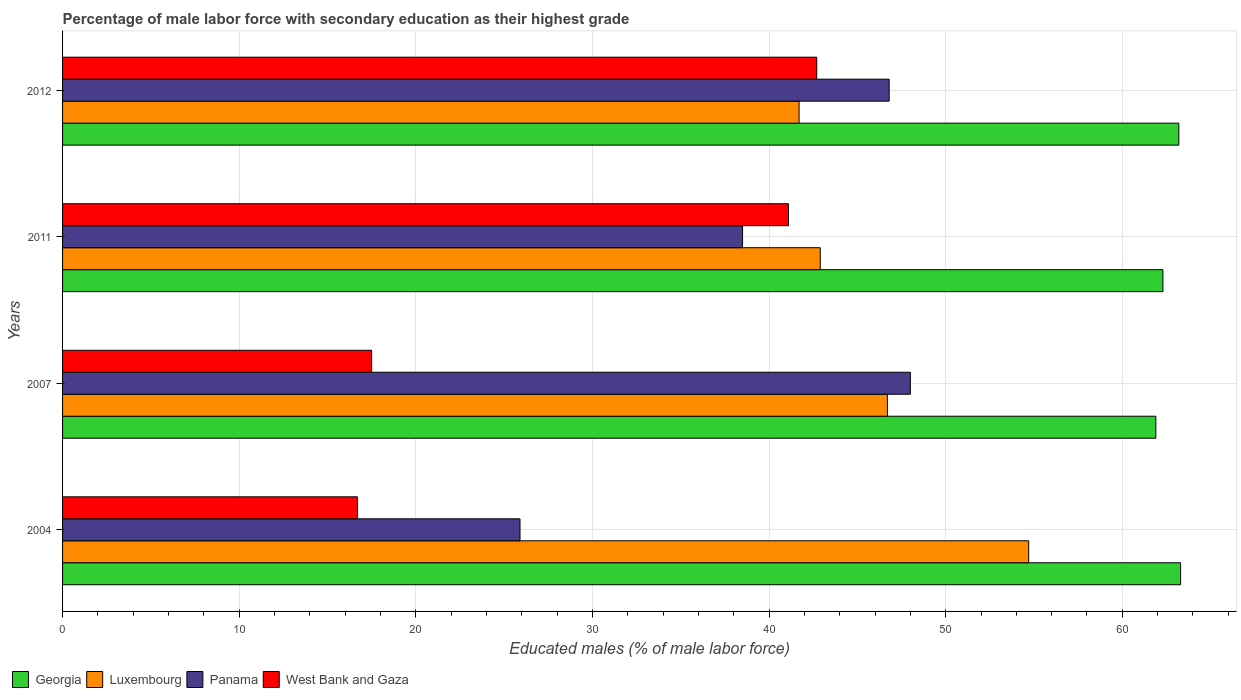How many different coloured bars are there?
Provide a succinct answer. 4. How many groups of bars are there?
Ensure brevity in your answer.  4. Are the number of bars on each tick of the Y-axis equal?
Provide a succinct answer. Yes. How many bars are there on the 3rd tick from the top?
Offer a very short reply. 4. How many bars are there on the 1st tick from the bottom?
Provide a succinct answer. 4. In how many cases, is the number of bars for a given year not equal to the number of legend labels?
Keep it short and to the point. 0. What is the percentage of male labor force with secondary education in Luxembourg in 2007?
Your answer should be very brief. 46.7. Across all years, what is the maximum percentage of male labor force with secondary education in Luxembourg?
Your answer should be very brief. 54.7. Across all years, what is the minimum percentage of male labor force with secondary education in Georgia?
Your response must be concise. 61.9. In which year was the percentage of male labor force with secondary education in West Bank and Gaza maximum?
Ensure brevity in your answer.  2012. What is the total percentage of male labor force with secondary education in West Bank and Gaza in the graph?
Offer a terse response. 118. What is the difference between the percentage of male labor force with secondary education in Georgia in 2004 and that in 2011?
Make the answer very short. 1. What is the difference between the percentage of male labor force with secondary education in West Bank and Gaza in 2004 and the percentage of male labor force with secondary education in Luxembourg in 2012?
Provide a succinct answer. -25. What is the average percentage of male labor force with secondary education in Luxembourg per year?
Give a very brief answer. 46.5. In the year 2012, what is the difference between the percentage of male labor force with secondary education in Luxembourg and percentage of male labor force with secondary education in Georgia?
Provide a succinct answer. -21.5. What is the ratio of the percentage of male labor force with secondary education in Luxembourg in 2004 to that in 2007?
Keep it short and to the point. 1.17. Is the percentage of male labor force with secondary education in West Bank and Gaza in 2007 less than that in 2012?
Provide a short and direct response. Yes. What is the difference between the highest and the second highest percentage of male labor force with secondary education in Georgia?
Make the answer very short. 0.1. What is the difference between the highest and the lowest percentage of male labor force with secondary education in Panama?
Make the answer very short. 22.1. In how many years, is the percentage of male labor force with secondary education in West Bank and Gaza greater than the average percentage of male labor force with secondary education in West Bank and Gaza taken over all years?
Your response must be concise. 2. What does the 2nd bar from the top in 2012 represents?
Offer a very short reply. Panama. What does the 2nd bar from the bottom in 2004 represents?
Make the answer very short. Luxembourg. Are all the bars in the graph horizontal?
Provide a short and direct response. Yes. How many years are there in the graph?
Make the answer very short. 4. What is the difference between two consecutive major ticks on the X-axis?
Provide a short and direct response. 10. Where does the legend appear in the graph?
Keep it short and to the point. Bottom left. What is the title of the graph?
Provide a short and direct response. Percentage of male labor force with secondary education as their highest grade. Does "Zimbabwe" appear as one of the legend labels in the graph?
Give a very brief answer. No. What is the label or title of the X-axis?
Keep it short and to the point. Educated males (% of male labor force). What is the label or title of the Y-axis?
Provide a succinct answer. Years. What is the Educated males (% of male labor force) of Georgia in 2004?
Give a very brief answer. 63.3. What is the Educated males (% of male labor force) in Luxembourg in 2004?
Ensure brevity in your answer.  54.7. What is the Educated males (% of male labor force) in Panama in 2004?
Provide a succinct answer. 25.9. What is the Educated males (% of male labor force) in West Bank and Gaza in 2004?
Your response must be concise. 16.7. What is the Educated males (% of male labor force) of Georgia in 2007?
Keep it short and to the point. 61.9. What is the Educated males (% of male labor force) in Luxembourg in 2007?
Give a very brief answer. 46.7. What is the Educated males (% of male labor force) of West Bank and Gaza in 2007?
Your response must be concise. 17.5. What is the Educated males (% of male labor force) of Georgia in 2011?
Offer a very short reply. 62.3. What is the Educated males (% of male labor force) in Luxembourg in 2011?
Your answer should be very brief. 42.9. What is the Educated males (% of male labor force) of Panama in 2011?
Keep it short and to the point. 38.5. What is the Educated males (% of male labor force) in West Bank and Gaza in 2011?
Keep it short and to the point. 41.1. What is the Educated males (% of male labor force) of Georgia in 2012?
Your answer should be very brief. 63.2. What is the Educated males (% of male labor force) in Luxembourg in 2012?
Offer a very short reply. 41.7. What is the Educated males (% of male labor force) of Panama in 2012?
Give a very brief answer. 46.8. What is the Educated males (% of male labor force) of West Bank and Gaza in 2012?
Ensure brevity in your answer.  42.7. Across all years, what is the maximum Educated males (% of male labor force) in Georgia?
Your response must be concise. 63.3. Across all years, what is the maximum Educated males (% of male labor force) in Luxembourg?
Your response must be concise. 54.7. Across all years, what is the maximum Educated males (% of male labor force) in West Bank and Gaza?
Your response must be concise. 42.7. Across all years, what is the minimum Educated males (% of male labor force) in Georgia?
Make the answer very short. 61.9. Across all years, what is the minimum Educated males (% of male labor force) of Luxembourg?
Offer a terse response. 41.7. Across all years, what is the minimum Educated males (% of male labor force) in Panama?
Your response must be concise. 25.9. Across all years, what is the minimum Educated males (% of male labor force) in West Bank and Gaza?
Your answer should be very brief. 16.7. What is the total Educated males (% of male labor force) in Georgia in the graph?
Provide a short and direct response. 250.7. What is the total Educated males (% of male labor force) of Luxembourg in the graph?
Provide a succinct answer. 186. What is the total Educated males (% of male labor force) in Panama in the graph?
Make the answer very short. 159.2. What is the total Educated males (% of male labor force) in West Bank and Gaza in the graph?
Your response must be concise. 118. What is the difference between the Educated males (% of male labor force) of Georgia in 2004 and that in 2007?
Ensure brevity in your answer.  1.4. What is the difference between the Educated males (% of male labor force) in Panama in 2004 and that in 2007?
Ensure brevity in your answer.  -22.1. What is the difference between the Educated males (% of male labor force) in Panama in 2004 and that in 2011?
Make the answer very short. -12.6. What is the difference between the Educated males (% of male labor force) in West Bank and Gaza in 2004 and that in 2011?
Offer a very short reply. -24.4. What is the difference between the Educated males (% of male labor force) of Georgia in 2004 and that in 2012?
Provide a succinct answer. 0.1. What is the difference between the Educated males (% of male labor force) of Luxembourg in 2004 and that in 2012?
Give a very brief answer. 13. What is the difference between the Educated males (% of male labor force) of Panama in 2004 and that in 2012?
Provide a short and direct response. -20.9. What is the difference between the Educated males (% of male labor force) in Georgia in 2007 and that in 2011?
Provide a short and direct response. -0.4. What is the difference between the Educated males (% of male labor force) of Luxembourg in 2007 and that in 2011?
Offer a very short reply. 3.8. What is the difference between the Educated males (% of male labor force) of Panama in 2007 and that in 2011?
Provide a succinct answer. 9.5. What is the difference between the Educated males (% of male labor force) of West Bank and Gaza in 2007 and that in 2011?
Make the answer very short. -23.6. What is the difference between the Educated males (% of male labor force) of Luxembourg in 2007 and that in 2012?
Your response must be concise. 5. What is the difference between the Educated males (% of male labor force) of Panama in 2007 and that in 2012?
Your answer should be compact. 1.2. What is the difference between the Educated males (% of male labor force) in West Bank and Gaza in 2007 and that in 2012?
Provide a short and direct response. -25.2. What is the difference between the Educated males (% of male labor force) in Panama in 2011 and that in 2012?
Your answer should be compact. -8.3. What is the difference between the Educated males (% of male labor force) in West Bank and Gaza in 2011 and that in 2012?
Ensure brevity in your answer.  -1.6. What is the difference between the Educated males (% of male labor force) in Georgia in 2004 and the Educated males (% of male labor force) in Luxembourg in 2007?
Offer a terse response. 16.6. What is the difference between the Educated males (% of male labor force) of Georgia in 2004 and the Educated males (% of male labor force) of Panama in 2007?
Offer a terse response. 15.3. What is the difference between the Educated males (% of male labor force) in Georgia in 2004 and the Educated males (% of male labor force) in West Bank and Gaza in 2007?
Your response must be concise. 45.8. What is the difference between the Educated males (% of male labor force) of Luxembourg in 2004 and the Educated males (% of male labor force) of Panama in 2007?
Provide a short and direct response. 6.7. What is the difference between the Educated males (% of male labor force) in Luxembourg in 2004 and the Educated males (% of male labor force) in West Bank and Gaza in 2007?
Give a very brief answer. 37.2. What is the difference between the Educated males (% of male labor force) in Panama in 2004 and the Educated males (% of male labor force) in West Bank and Gaza in 2007?
Keep it short and to the point. 8.4. What is the difference between the Educated males (% of male labor force) in Georgia in 2004 and the Educated males (% of male labor force) in Luxembourg in 2011?
Provide a succinct answer. 20.4. What is the difference between the Educated males (% of male labor force) in Georgia in 2004 and the Educated males (% of male labor force) in Panama in 2011?
Keep it short and to the point. 24.8. What is the difference between the Educated males (% of male labor force) in Luxembourg in 2004 and the Educated males (% of male labor force) in Panama in 2011?
Make the answer very short. 16.2. What is the difference between the Educated males (% of male labor force) of Luxembourg in 2004 and the Educated males (% of male labor force) of West Bank and Gaza in 2011?
Your answer should be very brief. 13.6. What is the difference between the Educated males (% of male labor force) in Panama in 2004 and the Educated males (% of male labor force) in West Bank and Gaza in 2011?
Provide a short and direct response. -15.2. What is the difference between the Educated males (% of male labor force) of Georgia in 2004 and the Educated males (% of male labor force) of Luxembourg in 2012?
Keep it short and to the point. 21.6. What is the difference between the Educated males (% of male labor force) in Georgia in 2004 and the Educated males (% of male labor force) in Panama in 2012?
Your answer should be very brief. 16.5. What is the difference between the Educated males (% of male labor force) in Georgia in 2004 and the Educated males (% of male labor force) in West Bank and Gaza in 2012?
Offer a terse response. 20.6. What is the difference between the Educated males (% of male labor force) of Luxembourg in 2004 and the Educated males (% of male labor force) of Panama in 2012?
Make the answer very short. 7.9. What is the difference between the Educated males (% of male labor force) in Luxembourg in 2004 and the Educated males (% of male labor force) in West Bank and Gaza in 2012?
Ensure brevity in your answer.  12. What is the difference between the Educated males (% of male labor force) in Panama in 2004 and the Educated males (% of male labor force) in West Bank and Gaza in 2012?
Ensure brevity in your answer.  -16.8. What is the difference between the Educated males (% of male labor force) of Georgia in 2007 and the Educated males (% of male labor force) of Panama in 2011?
Make the answer very short. 23.4. What is the difference between the Educated males (% of male labor force) in Georgia in 2007 and the Educated males (% of male labor force) in West Bank and Gaza in 2011?
Keep it short and to the point. 20.8. What is the difference between the Educated males (% of male labor force) of Luxembourg in 2007 and the Educated males (% of male labor force) of Panama in 2011?
Offer a terse response. 8.2. What is the difference between the Educated males (% of male labor force) in Luxembourg in 2007 and the Educated males (% of male labor force) in West Bank and Gaza in 2011?
Make the answer very short. 5.6. What is the difference between the Educated males (% of male labor force) in Georgia in 2007 and the Educated males (% of male labor force) in Luxembourg in 2012?
Your response must be concise. 20.2. What is the difference between the Educated males (% of male labor force) of Luxembourg in 2007 and the Educated males (% of male labor force) of Panama in 2012?
Provide a succinct answer. -0.1. What is the difference between the Educated males (% of male labor force) of Luxembourg in 2007 and the Educated males (% of male labor force) of West Bank and Gaza in 2012?
Provide a short and direct response. 4. What is the difference between the Educated males (% of male labor force) in Panama in 2007 and the Educated males (% of male labor force) in West Bank and Gaza in 2012?
Ensure brevity in your answer.  5.3. What is the difference between the Educated males (% of male labor force) in Georgia in 2011 and the Educated males (% of male labor force) in Luxembourg in 2012?
Offer a very short reply. 20.6. What is the difference between the Educated males (% of male labor force) in Georgia in 2011 and the Educated males (% of male labor force) in West Bank and Gaza in 2012?
Make the answer very short. 19.6. What is the difference between the Educated males (% of male labor force) of Luxembourg in 2011 and the Educated males (% of male labor force) of Panama in 2012?
Ensure brevity in your answer.  -3.9. What is the difference between the Educated males (% of male labor force) in Panama in 2011 and the Educated males (% of male labor force) in West Bank and Gaza in 2012?
Your response must be concise. -4.2. What is the average Educated males (% of male labor force) of Georgia per year?
Keep it short and to the point. 62.67. What is the average Educated males (% of male labor force) of Luxembourg per year?
Ensure brevity in your answer.  46.5. What is the average Educated males (% of male labor force) in Panama per year?
Ensure brevity in your answer.  39.8. What is the average Educated males (% of male labor force) of West Bank and Gaza per year?
Your answer should be compact. 29.5. In the year 2004, what is the difference between the Educated males (% of male labor force) in Georgia and Educated males (% of male labor force) in Panama?
Offer a terse response. 37.4. In the year 2004, what is the difference between the Educated males (% of male labor force) in Georgia and Educated males (% of male labor force) in West Bank and Gaza?
Your answer should be compact. 46.6. In the year 2004, what is the difference between the Educated males (% of male labor force) of Luxembourg and Educated males (% of male labor force) of Panama?
Your answer should be compact. 28.8. In the year 2004, what is the difference between the Educated males (% of male labor force) of Luxembourg and Educated males (% of male labor force) of West Bank and Gaza?
Give a very brief answer. 38. In the year 2004, what is the difference between the Educated males (% of male labor force) of Panama and Educated males (% of male labor force) of West Bank and Gaza?
Offer a very short reply. 9.2. In the year 2007, what is the difference between the Educated males (% of male labor force) of Georgia and Educated males (% of male labor force) of West Bank and Gaza?
Offer a terse response. 44.4. In the year 2007, what is the difference between the Educated males (% of male labor force) of Luxembourg and Educated males (% of male labor force) of Panama?
Give a very brief answer. -1.3. In the year 2007, what is the difference between the Educated males (% of male labor force) of Luxembourg and Educated males (% of male labor force) of West Bank and Gaza?
Your response must be concise. 29.2. In the year 2007, what is the difference between the Educated males (% of male labor force) of Panama and Educated males (% of male labor force) of West Bank and Gaza?
Keep it short and to the point. 30.5. In the year 2011, what is the difference between the Educated males (% of male labor force) in Georgia and Educated males (% of male labor force) in Panama?
Make the answer very short. 23.8. In the year 2011, what is the difference between the Educated males (% of male labor force) of Georgia and Educated males (% of male labor force) of West Bank and Gaza?
Provide a short and direct response. 21.2. In the year 2011, what is the difference between the Educated males (% of male labor force) of Panama and Educated males (% of male labor force) of West Bank and Gaza?
Make the answer very short. -2.6. In the year 2012, what is the difference between the Educated males (% of male labor force) of Georgia and Educated males (% of male labor force) of Panama?
Make the answer very short. 16.4. In the year 2012, what is the difference between the Educated males (% of male labor force) in Panama and Educated males (% of male labor force) in West Bank and Gaza?
Ensure brevity in your answer.  4.1. What is the ratio of the Educated males (% of male labor force) in Georgia in 2004 to that in 2007?
Your response must be concise. 1.02. What is the ratio of the Educated males (% of male labor force) in Luxembourg in 2004 to that in 2007?
Your answer should be very brief. 1.17. What is the ratio of the Educated males (% of male labor force) of Panama in 2004 to that in 2007?
Offer a terse response. 0.54. What is the ratio of the Educated males (% of male labor force) of West Bank and Gaza in 2004 to that in 2007?
Your response must be concise. 0.95. What is the ratio of the Educated males (% of male labor force) of Georgia in 2004 to that in 2011?
Offer a terse response. 1.02. What is the ratio of the Educated males (% of male labor force) of Luxembourg in 2004 to that in 2011?
Provide a succinct answer. 1.28. What is the ratio of the Educated males (% of male labor force) of Panama in 2004 to that in 2011?
Ensure brevity in your answer.  0.67. What is the ratio of the Educated males (% of male labor force) in West Bank and Gaza in 2004 to that in 2011?
Offer a terse response. 0.41. What is the ratio of the Educated males (% of male labor force) of Luxembourg in 2004 to that in 2012?
Provide a short and direct response. 1.31. What is the ratio of the Educated males (% of male labor force) of Panama in 2004 to that in 2012?
Provide a succinct answer. 0.55. What is the ratio of the Educated males (% of male labor force) in West Bank and Gaza in 2004 to that in 2012?
Offer a very short reply. 0.39. What is the ratio of the Educated males (% of male labor force) in Georgia in 2007 to that in 2011?
Your response must be concise. 0.99. What is the ratio of the Educated males (% of male labor force) of Luxembourg in 2007 to that in 2011?
Your response must be concise. 1.09. What is the ratio of the Educated males (% of male labor force) of Panama in 2007 to that in 2011?
Your response must be concise. 1.25. What is the ratio of the Educated males (% of male labor force) of West Bank and Gaza in 2007 to that in 2011?
Provide a succinct answer. 0.43. What is the ratio of the Educated males (% of male labor force) of Georgia in 2007 to that in 2012?
Your response must be concise. 0.98. What is the ratio of the Educated males (% of male labor force) of Luxembourg in 2007 to that in 2012?
Keep it short and to the point. 1.12. What is the ratio of the Educated males (% of male labor force) in Panama in 2007 to that in 2012?
Your answer should be very brief. 1.03. What is the ratio of the Educated males (% of male labor force) in West Bank and Gaza in 2007 to that in 2012?
Your answer should be compact. 0.41. What is the ratio of the Educated males (% of male labor force) of Georgia in 2011 to that in 2012?
Offer a very short reply. 0.99. What is the ratio of the Educated males (% of male labor force) in Luxembourg in 2011 to that in 2012?
Keep it short and to the point. 1.03. What is the ratio of the Educated males (% of male labor force) of Panama in 2011 to that in 2012?
Your answer should be very brief. 0.82. What is the ratio of the Educated males (% of male labor force) of West Bank and Gaza in 2011 to that in 2012?
Your response must be concise. 0.96. What is the difference between the highest and the lowest Educated males (% of male labor force) in Panama?
Offer a terse response. 22.1. What is the difference between the highest and the lowest Educated males (% of male labor force) of West Bank and Gaza?
Give a very brief answer. 26. 